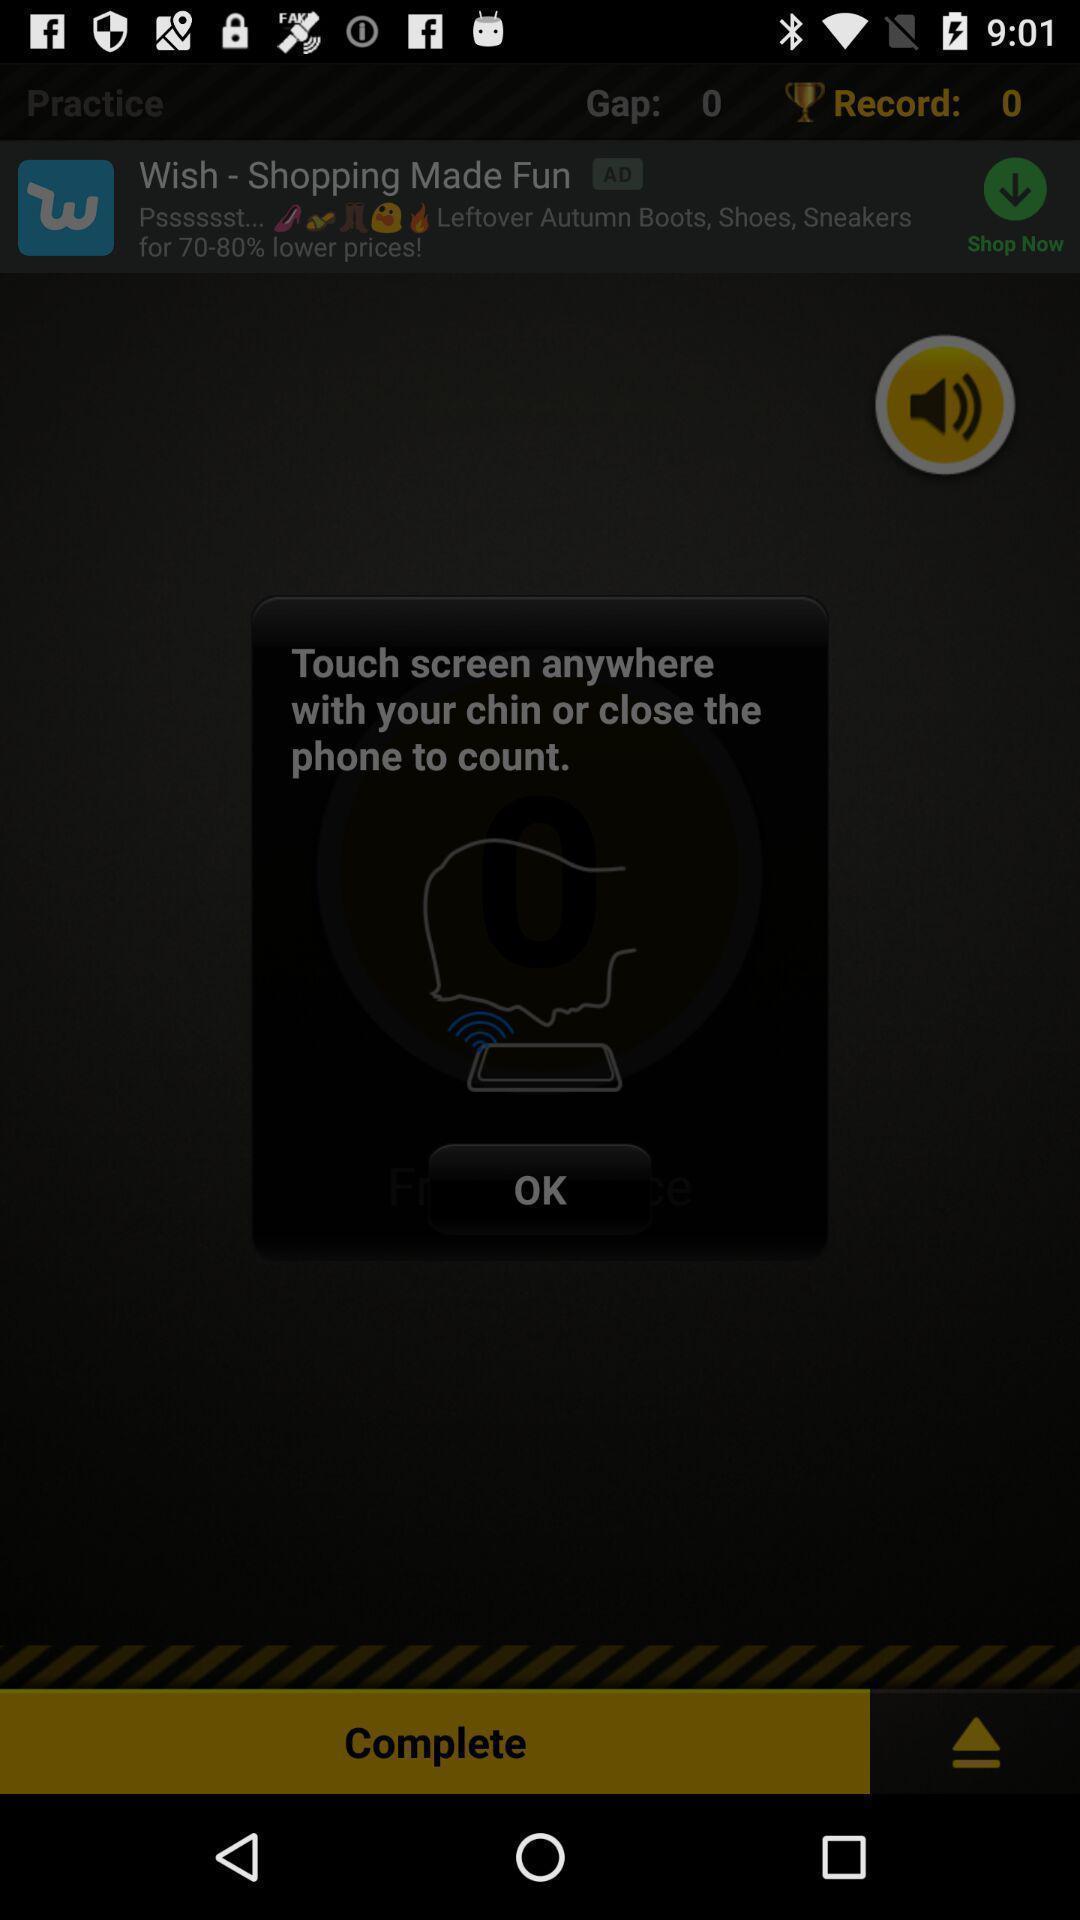Describe the content in this image. Screen displaying controls information to access an application. 